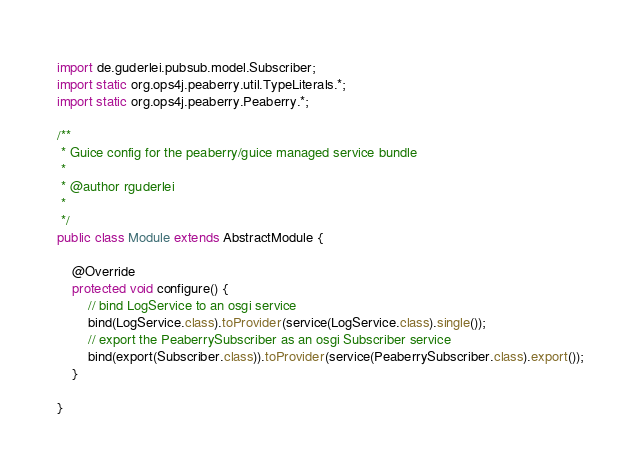Convert code to text. <code><loc_0><loc_0><loc_500><loc_500><_Java_>import de.guderlei.pubsub.model.Subscriber;
import static org.ops4j.peaberry.util.TypeLiterals.*;
import static org.ops4j.peaberry.Peaberry.*;

/**
 * Guice config for the peaberry/guice managed service bundle
 * 
 * @author rguderlei
 *
 */
public class Module extends AbstractModule {

	@Override
	protected void configure() {
		// bind LogService to an osgi service
		bind(LogService.class).toProvider(service(LogService.class).single());
		// export the PeaberrySubscriber as an osgi Subscriber service
		bind(export(Subscriber.class)).toProvider(service(PeaberrySubscriber.class).export());
	}

}
</code> 